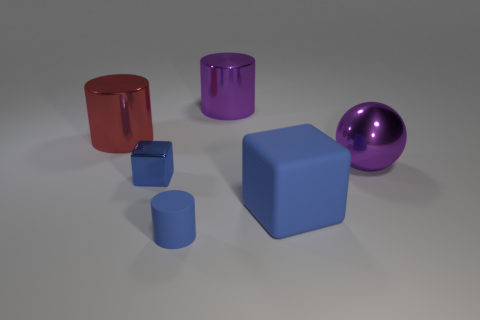Subtract all blue matte cylinders. How many cylinders are left? 2 Add 3 purple metal cylinders. How many objects exist? 9 Subtract all purple cylinders. How many cylinders are left? 2 Add 1 purple cylinders. How many purple cylinders are left? 2 Add 2 big brown rubber objects. How many big brown rubber objects exist? 2 Subtract 1 purple spheres. How many objects are left? 5 Subtract all cubes. How many objects are left? 4 Subtract 1 cubes. How many cubes are left? 1 Subtract all gray balls. Subtract all green cylinders. How many balls are left? 1 Subtract all large purple objects. Subtract all small blue rubber cylinders. How many objects are left? 3 